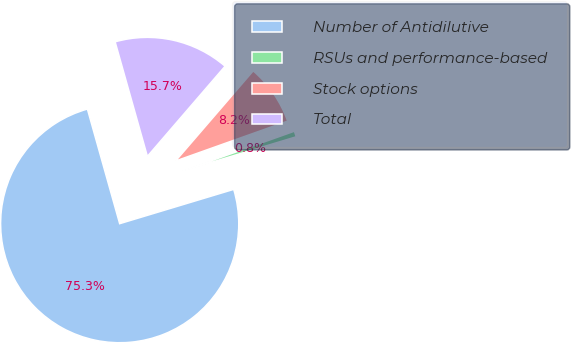<chart> <loc_0><loc_0><loc_500><loc_500><pie_chart><fcel>Number of Antidilutive<fcel>RSUs and performance-based<fcel>Stock options<fcel>Total<nl><fcel>75.29%<fcel>0.79%<fcel>8.24%<fcel>15.69%<nl></chart> 